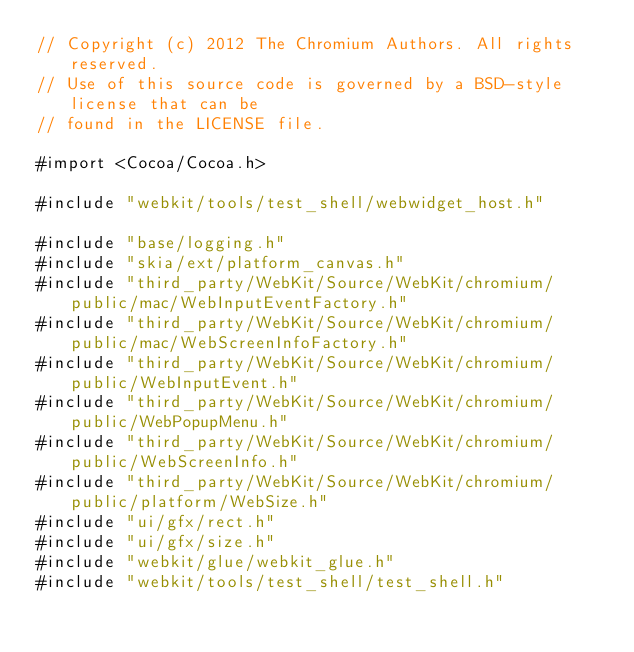<code> <loc_0><loc_0><loc_500><loc_500><_ObjectiveC_>// Copyright (c) 2012 The Chromium Authors. All rights reserved.
// Use of this source code is governed by a BSD-style license that can be
// found in the LICENSE file.

#import <Cocoa/Cocoa.h>

#include "webkit/tools/test_shell/webwidget_host.h"

#include "base/logging.h"
#include "skia/ext/platform_canvas.h"
#include "third_party/WebKit/Source/WebKit/chromium/public/mac/WebInputEventFactory.h"
#include "third_party/WebKit/Source/WebKit/chromium/public/mac/WebScreenInfoFactory.h"
#include "third_party/WebKit/Source/WebKit/chromium/public/WebInputEvent.h"
#include "third_party/WebKit/Source/WebKit/chromium/public/WebPopupMenu.h"
#include "third_party/WebKit/Source/WebKit/chromium/public/WebScreenInfo.h"
#include "third_party/WebKit/Source/WebKit/chromium/public/platform/WebSize.h"
#include "ui/gfx/rect.h"
#include "ui/gfx/size.h"
#include "webkit/glue/webkit_glue.h"
#include "webkit/tools/test_shell/test_shell.h"
</code> 